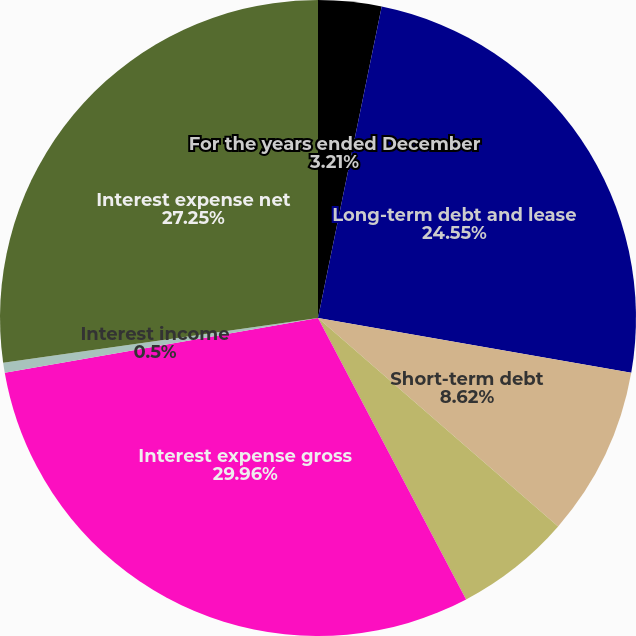Convert chart to OTSL. <chart><loc_0><loc_0><loc_500><loc_500><pie_chart><fcel>For the years ended December<fcel>Long-term debt and lease<fcel>Short-term debt<fcel>Capitalized interest<fcel>Interest expense gross<fcel>Interest income<fcel>Interest expense net<nl><fcel>3.21%<fcel>24.55%<fcel>8.62%<fcel>5.91%<fcel>29.96%<fcel>0.5%<fcel>27.25%<nl></chart> 